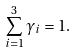<formula> <loc_0><loc_0><loc_500><loc_500>\sum _ { i = 1 } ^ { 3 } \gamma _ { i } = 1 .</formula> 